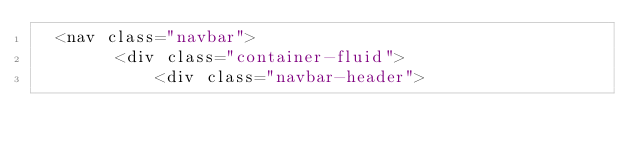<code> <loc_0><loc_0><loc_500><loc_500><_PHP_>  <nav class="navbar">
        <div class="container-fluid">
            <div class="navbar-header"></code> 